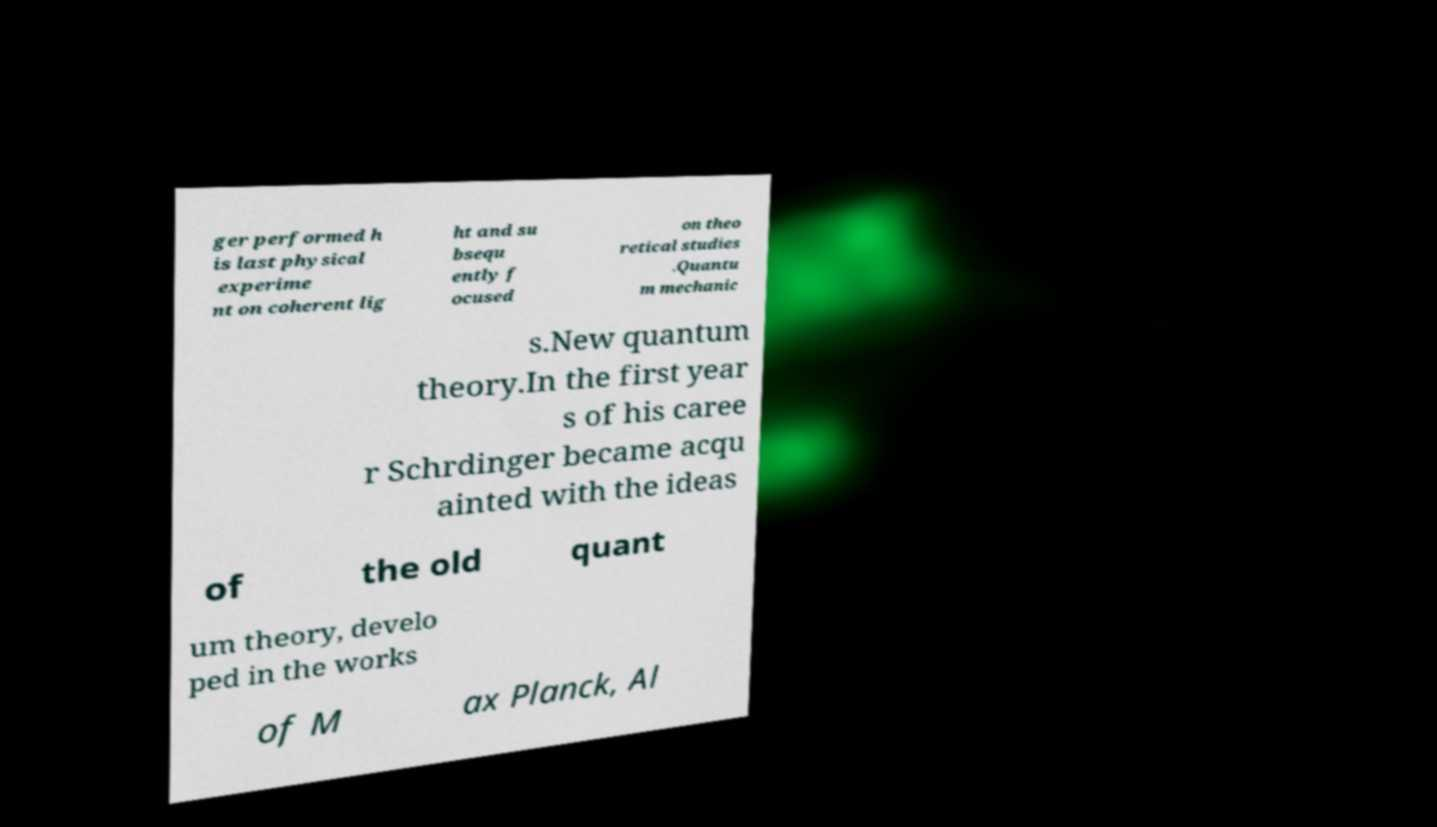Can you accurately transcribe the text from the provided image for me? ger performed h is last physical experime nt on coherent lig ht and su bsequ ently f ocused on theo retical studies .Quantu m mechanic s.New quantum theory.In the first year s of his caree r Schrdinger became acqu ainted with the ideas of the old quant um theory, develo ped in the works of M ax Planck, Al 